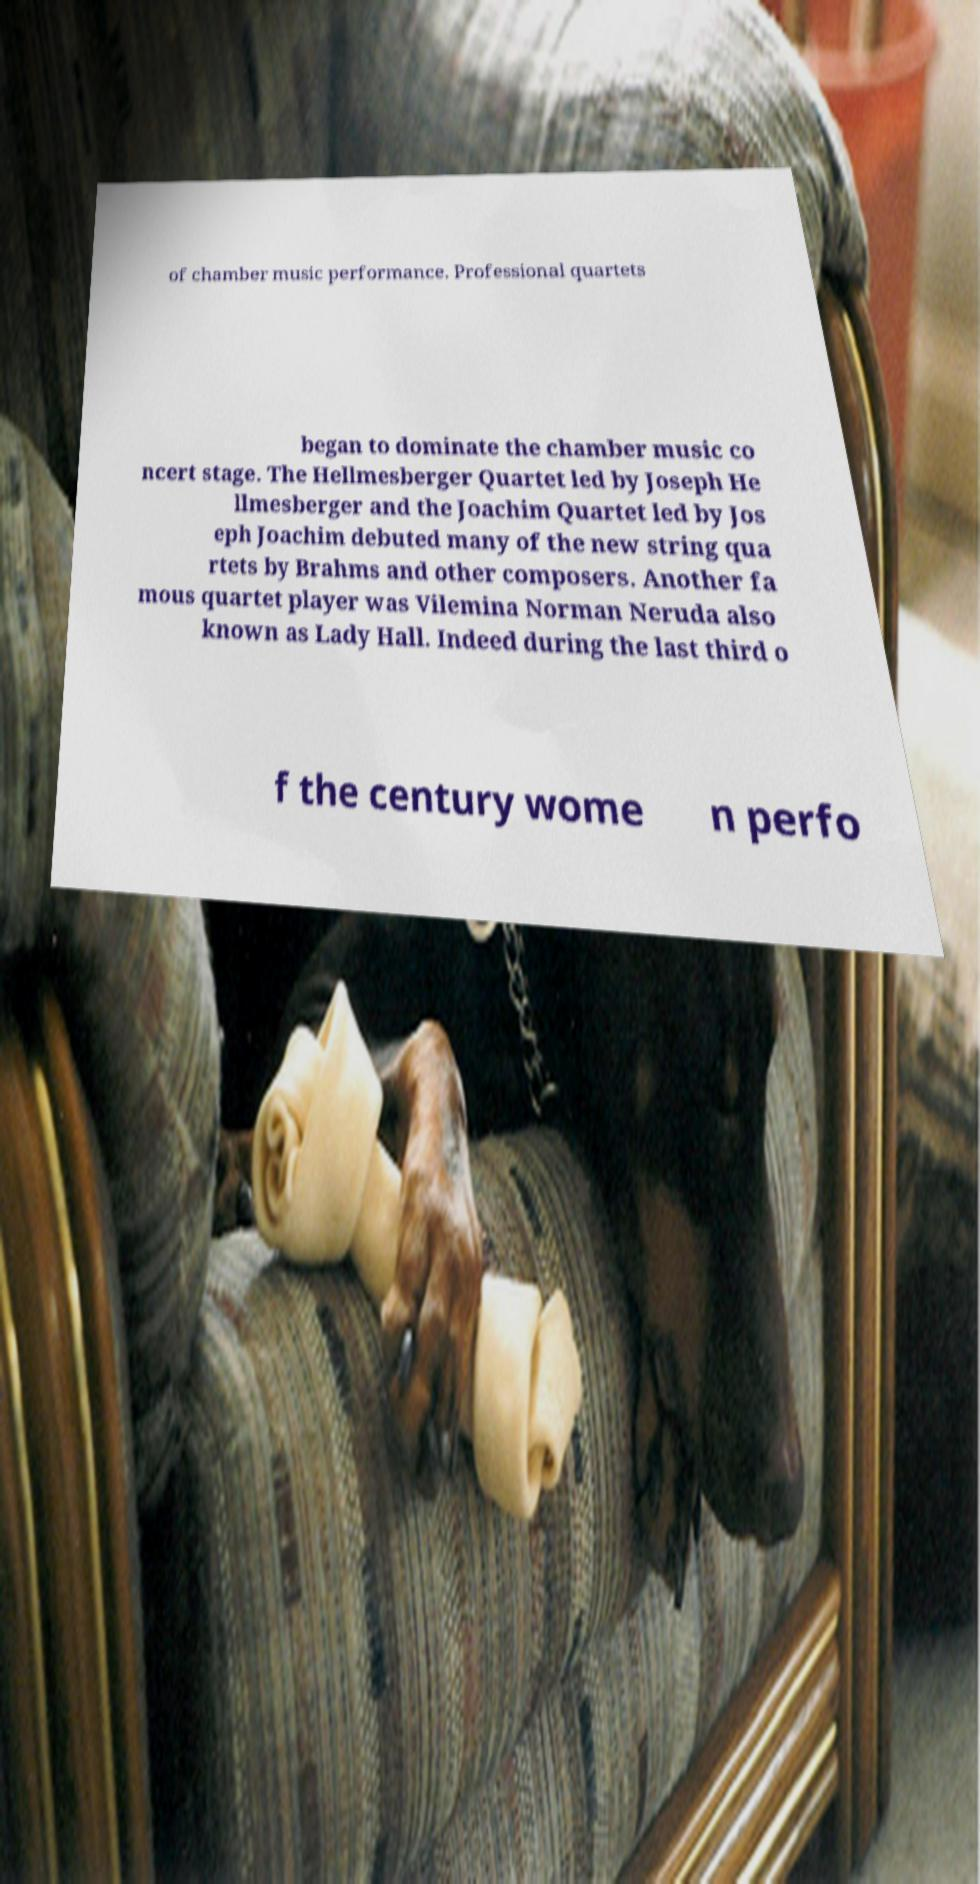There's text embedded in this image that I need extracted. Can you transcribe it verbatim? of chamber music performance. Professional quartets began to dominate the chamber music co ncert stage. The Hellmesberger Quartet led by Joseph He llmesberger and the Joachim Quartet led by Jos eph Joachim debuted many of the new string qua rtets by Brahms and other composers. Another fa mous quartet player was Vilemina Norman Neruda also known as Lady Hall. Indeed during the last third o f the century wome n perfo 